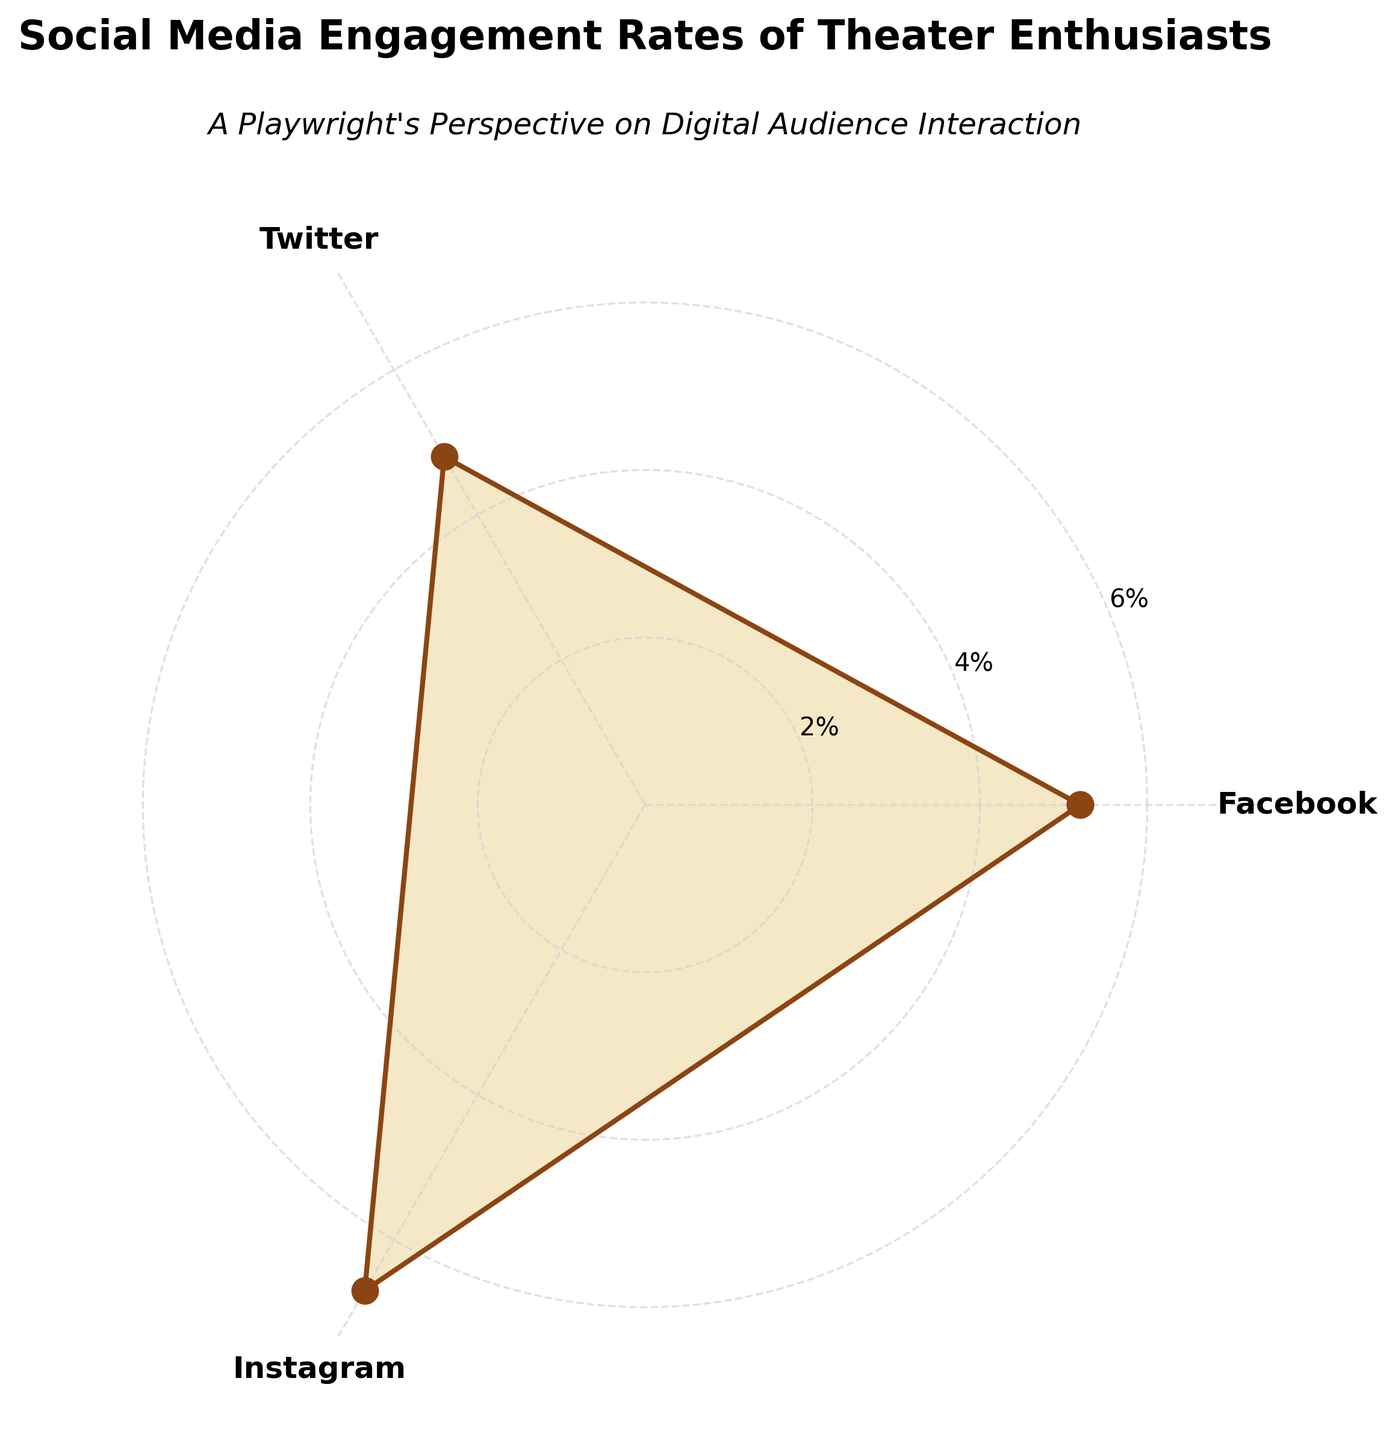What is the title of the plot? The title of the plot is located at the top center of the chart and reads, "Social Media Engagement Rates of Theater Enthusiasts".
Answer: Social Media Engagement Rates of Theater Enthusiasts Which social media platform has the highest engagement rate? By examining the lengths of the lines extending from the center of the rose chart, we can see that the line for Instagram extends the furthest, indicating it has the highest engagement rate.
Answer: Instagram How does the engagement rate of Facebook compare to Twitter? By comparing the lengths of the lines for Facebook and Twitter, we note that the line for Facebook extends slightly further than the one for Twitter, indicating a higher engagement rate for Facebook.
Answer: Facebook has a higher engagement rate than Twitter What is the color of the lines indicating engagement rates? Observing the chart, the lines indicating engagement rates are colored in a deep brown shade.
Answer: Deep brown What is the average engagement rate across all platforms? First, sum up the engagement rates for Facebook (5.2%), Twitter (4.8%), and Instagram (6.7%), which gives us 16.7%. Then, divide by the number of platforms, 16.7%/3 = 5.57%.
Answer: 5.57% What is the difference between the highest and lowest engagement rates? The highest engagement rate is for Instagram at 6.7%, and the lowest is for Twitter at 4.8%. Subtract the lowest rate from the highest rate: 6.7% - 4.8% = 1.9%.
Answer: 1.9% What are the platforms listed on the chart? The radial labels on the chart show the platforms listed as Facebook, Twitter, and Instagram.
Answer: Facebook, Twitter, Instagram Which platform has the median engagement rate, and what is it? Arrange the engagement rates in ascending order: Twitter (4.8%), Facebook (5.2%), Instagram (6.7%). The middle value is Facebook with an engagement rate of 5.2%.
Answer: Facebook, 5.2% Is the engagement rate for Twitter higher or lower than the average engagement rate? The average engagement rate across all platforms is 5.57%. By comparing, Twitter's engagement rate of 4.8% is lower than the overall average.
Answer: Lower Explain how the rose chart visually represents engagement rates. In the rose chart, engagement rates are represented by the length of the lines extending from the center towards the outer edge. Each platform's engagement rate corresponds to one of these lines, with higher engagement rates having longer lines. Additionally, the area enclosed within each line can be filled to enhance the visual distinction of different engagement rates.
Answer: N/A 